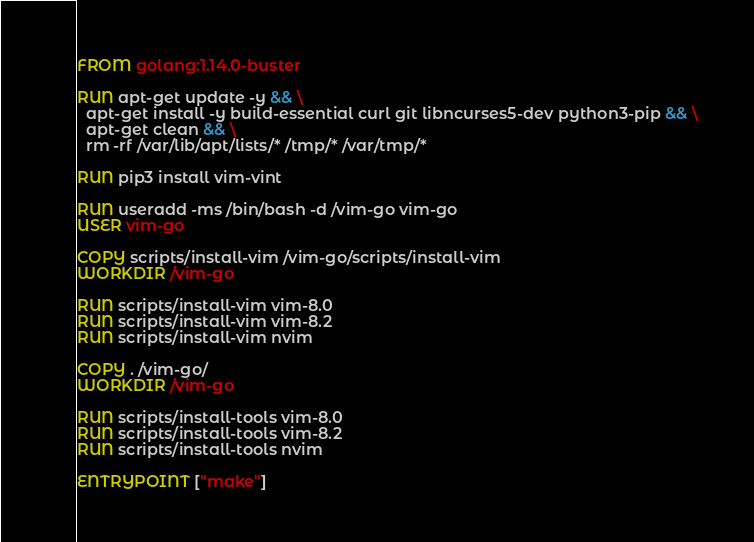<code> <loc_0><loc_0><loc_500><loc_500><_Dockerfile_>FROM golang:1.14.0-buster

RUN apt-get update -y && \
  apt-get install -y build-essential curl git libncurses5-dev python3-pip && \
  apt-get clean && \
  rm -rf /var/lib/apt/lists/* /tmp/* /var/tmp/*

RUN pip3 install vim-vint

RUN useradd -ms /bin/bash -d /vim-go vim-go
USER vim-go

COPY scripts/install-vim /vim-go/scripts/install-vim
WORKDIR /vim-go

RUN scripts/install-vim vim-8.0
RUN scripts/install-vim vim-8.2
RUN scripts/install-vim nvim

COPY . /vim-go/
WORKDIR /vim-go

RUN scripts/install-tools vim-8.0
RUN scripts/install-tools vim-8.2
RUN scripts/install-tools nvim

ENTRYPOINT ["make"]
</code> 